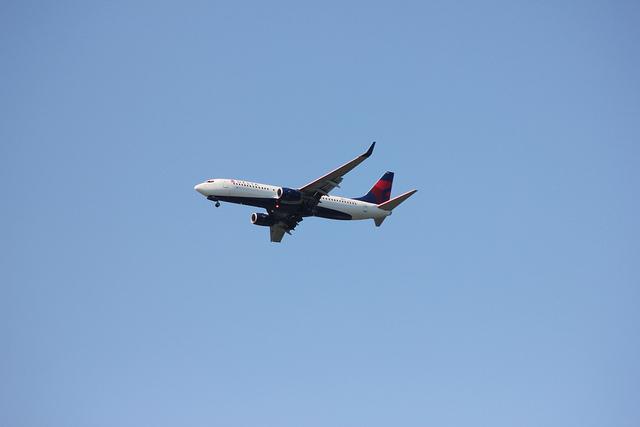Are there clouds that are visible?
Be succinct. No. Are there any clouds in the sky?
Quick response, please. No. What is in the air?
Write a very short answer. Airplane. When compared to other planes, would this one be small?
Short answer required. No. How many clouds are in the sky?
Keep it brief. 0. It's not a bird, and it's not superman, so it must be a what?
Be succinct. Plane. Is this a standard passenger airplane?
Short answer required. Yes. What country's flag is being displayed on tail of the plane?
Be succinct. None. 